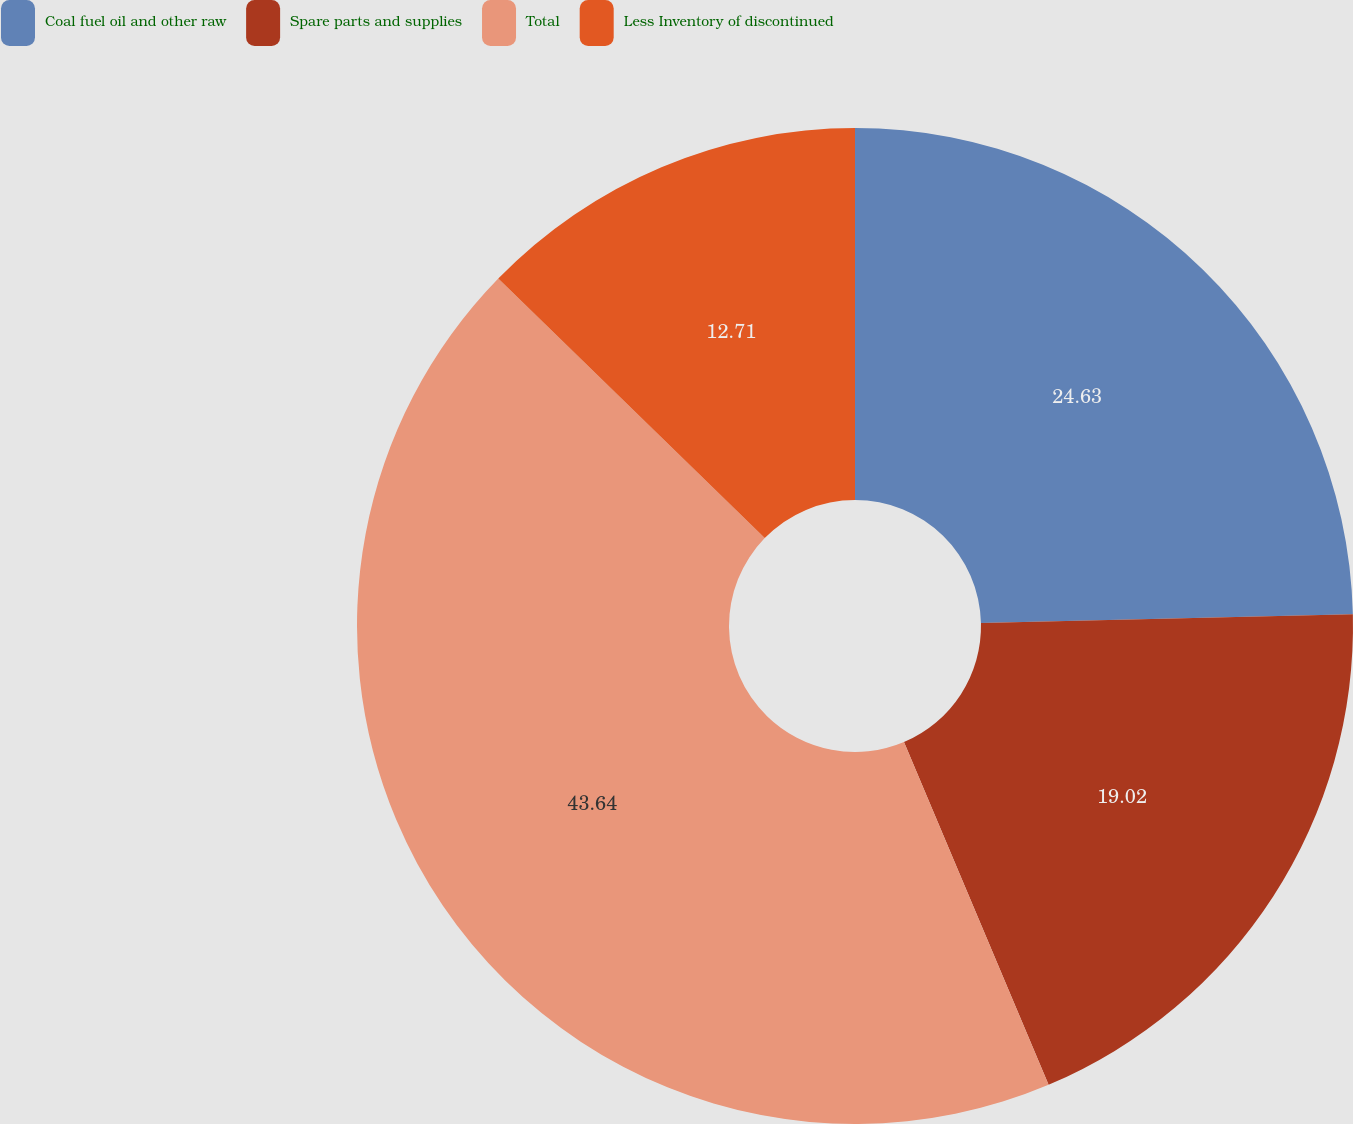Convert chart. <chart><loc_0><loc_0><loc_500><loc_500><pie_chart><fcel>Coal fuel oil and other raw<fcel>Spare parts and supplies<fcel>Total<fcel>Less Inventory of discontinued<nl><fcel>24.63%<fcel>19.02%<fcel>43.65%<fcel>12.71%<nl></chart> 